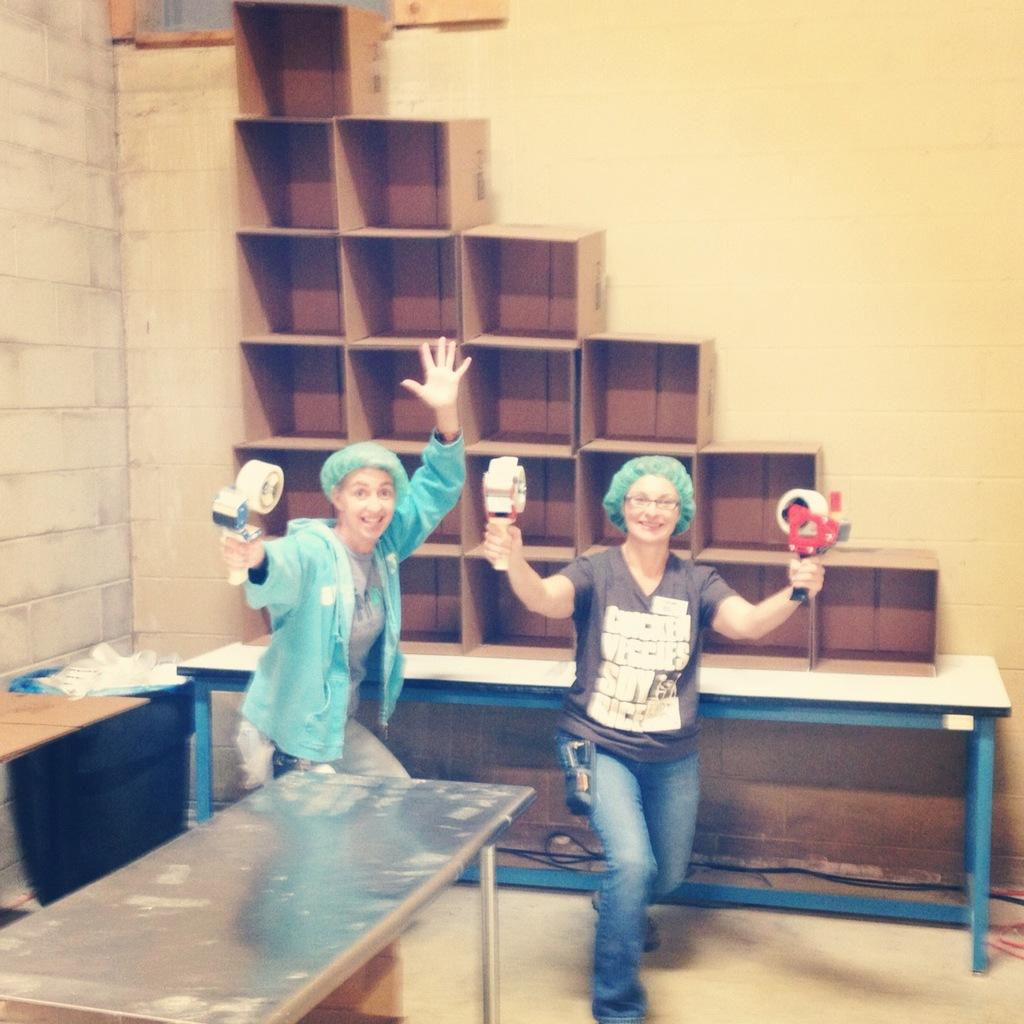How many women are in the image? There are two women in the image. What are the women doing in the image? The women are standing and holding objects. What can be seen on the tables in the image? There are objects on the tables in the image. What is visible in the background of the image? There is a wall in the background of the image. What type of map can be seen on the table in the image? There is no map present on the table in the image. What type of chess pieces are visible on the wall in the image? There is no chess or chess pieces visible on the wall in the image. 